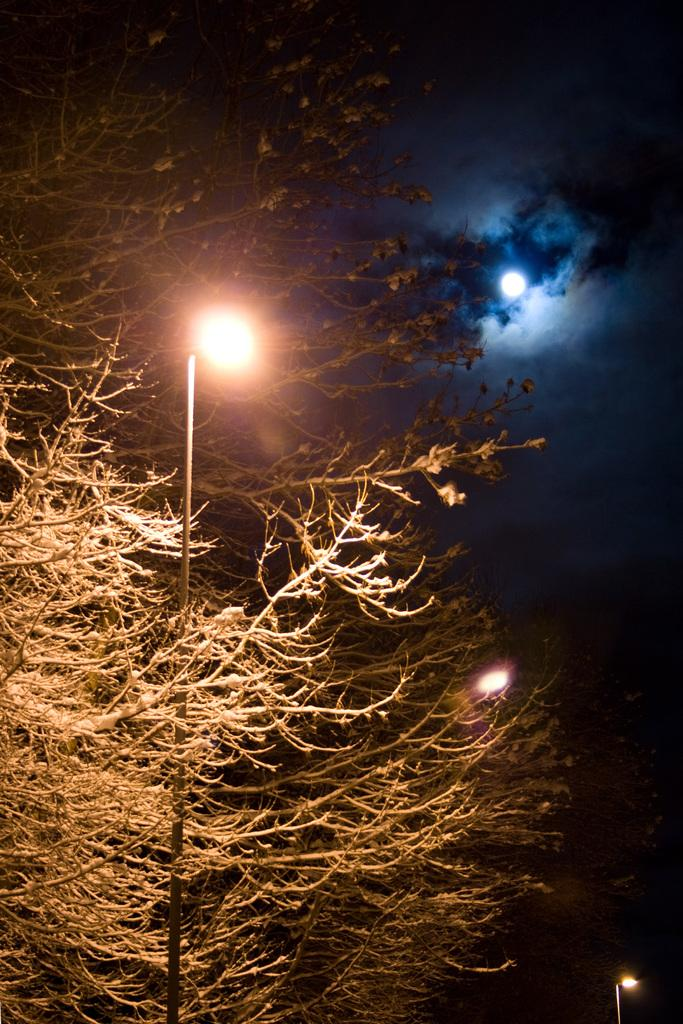What structures are present in the image? There are light poles in the image. What type of natural elements can be seen in the image? There are trees in the image. What is visible in the background of the image? The sky is visible in the background of the image. How would you describe the sky in the image? The sky appears to be cloudy. Where is the kitty playing with cream in the image? There is no kitty or cream present in the image. What type of land can be seen in the image? The image does not show any specific type of land; it only features light poles, trees, and the sky. 